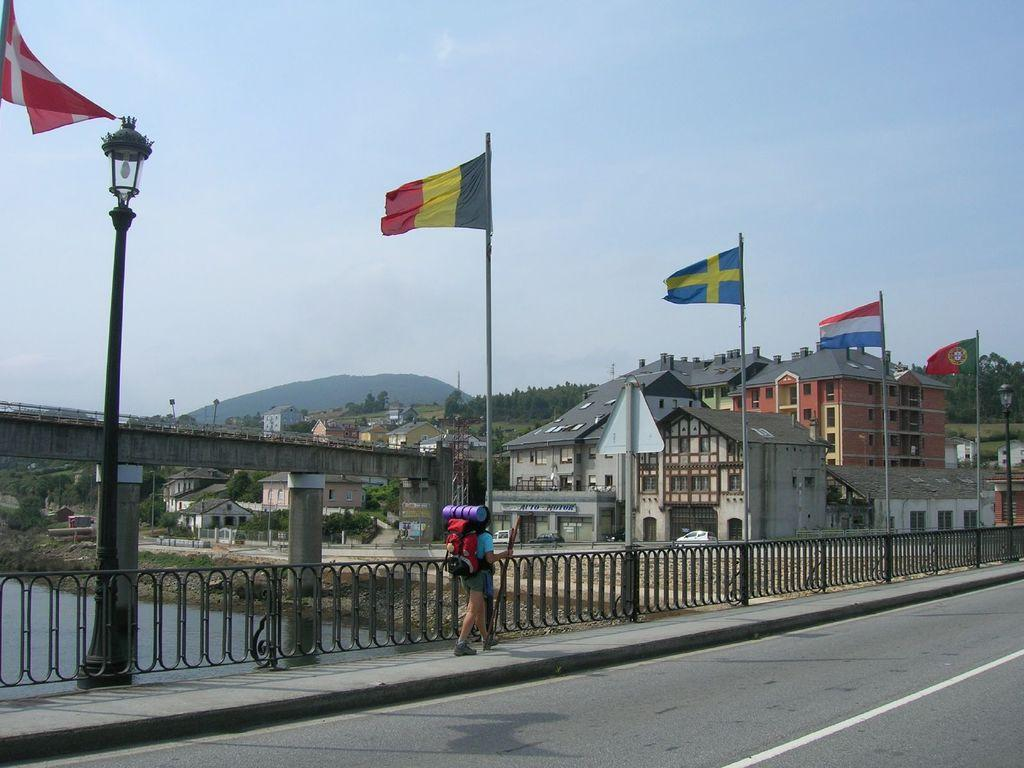What type of structure can be seen in the image? There is a fence in the image. Can you describe the man in the image? The man is wearing a bag in the image. What is the purpose of the street lamp in the image? The street lamp provides light in the image. What can be seen flying or hanging in the image? There are flags in the image. What natural feature is visible in the image? There is water visible in the image. What type of structure is present over the water? There is a bridge in the image. image. What type of man-made structures are visible in the image? There are buildings in the image. What type of landscape feature is visible in the image? There are hills in the image. What part of the natural environment is visible in the image? The sky is visible in the image. Where is the desk located in the image? There is no desk present in the image. Can you describe the goose that is walking on the bridge in the image? There is no goose present in the image. 